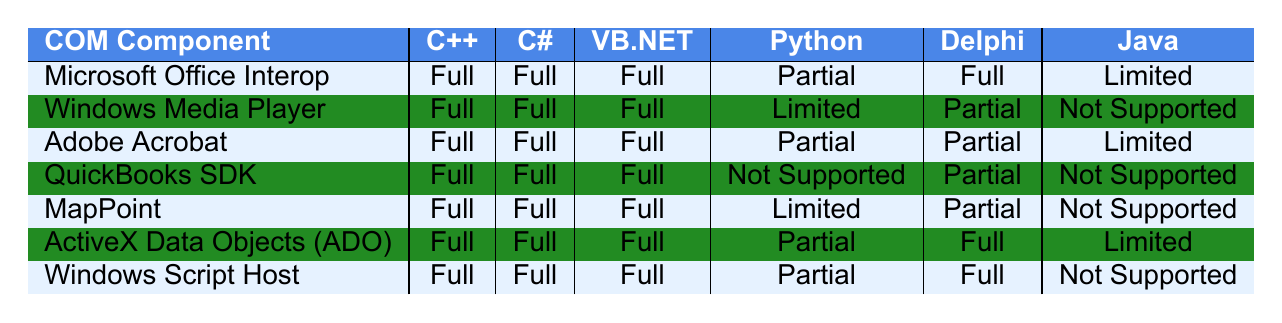What is the compatibility level of Microsoft Office Interop with C#? According to the table, the compatibility level of Microsoft Office Interop with C# is "Full".
Answer: Full Which programming language has "Not Supported" compatibility with QuickBooks SDK? The table indicates that both Python and Java have "Not Supported" compatibility with QuickBooks SDK.
Answer: Python, Java Is VB.NET fully compatible with Adobe Acrobat? The compatibility level of VB.NET with Adobe Acrobat is listed as "Full" in the table.
Answer: Yes How many programming languages have "Limited" compatibility with Windows Media Player? The table shows that only Python has "Limited" compatibility with Windows Media Player.
Answer: 1 Which COM component has the most "Partial" compatibility across the listed programming languages? Observing the table, both Windows Media Player and MapPoint have "Partial" compatibility with Delphi and Python, but MapPoint also has "Partial" with Delphi making it distributed across three languages in total.
Answer: Windows Media Player, MapPoint Are there any programming languages that have no compatibility with the Windows Script Host? The table shows that Java is the only programming language listed as "Not Supported" with Windows Script Host.
Answer: Yes What is the total number of programming languages that have "Full" compatibility with Microsoft Office Interop? According to the table, Microsoft Office Interop has "Full" compatibility with C++, C#, VB.NET, and Delphi, totaling four programming languages.
Answer: 4 Can you list all programming languages that have "Limited" compatibility with any COM component? The table shows Python and Java as having "Limited" compatibility with various components like Microsoft Office Interop, Windows Media Player, Adobe Acrobat, and ActiveX Data Objects.
Answer: Python, Java Which two COM components have the same compatibility status across all programming languages? The table indicates that the compatibility status differs across languages for each listed component, so no two components have the same status across all languages.
Answer: None If a user wants to work with a language that does not support QuickBooks SDK, what options are available? The table reveals that QuickBooks SDK is not supported by Python and Java, so users can consider C++, C#, or VB.NET as alternatives.
Answer: C++, C#, VB.NET 